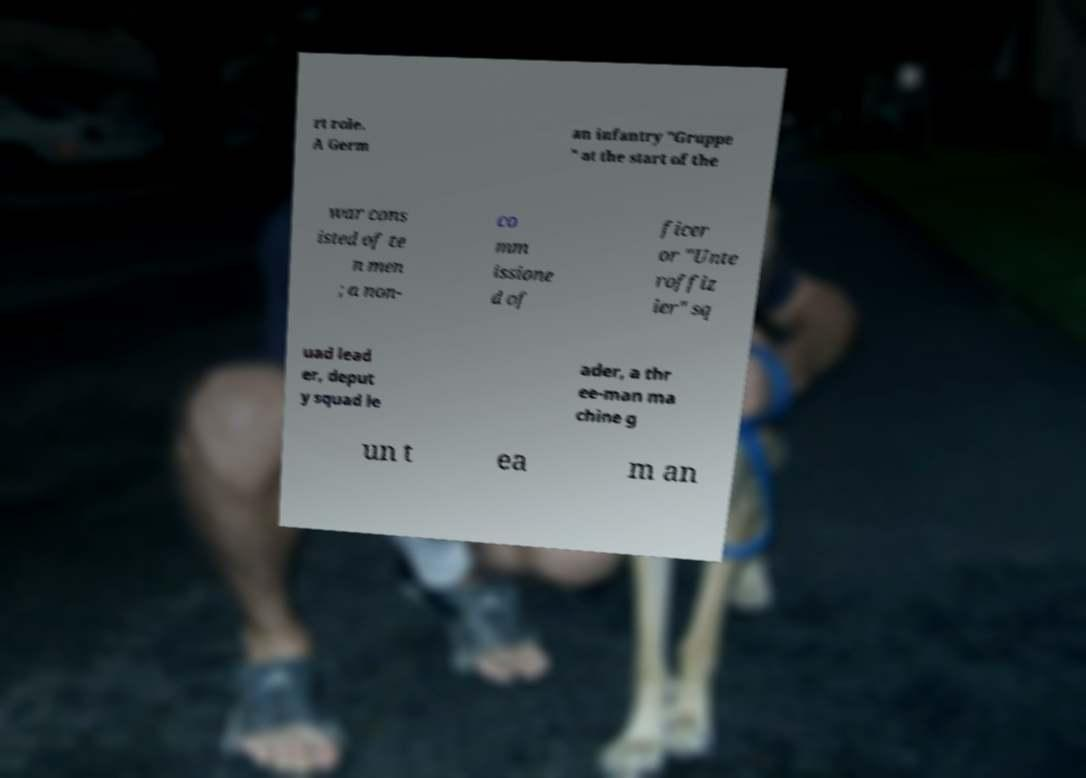I need the written content from this picture converted into text. Can you do that? rt role. A Germ an infantry "Gruppe " at the start of the war cons isted of te n men ; a non- co mm issione d of ficer or "Unte roffiz ier" sq uad lead er, deput y squad le ader, a thr ee-man ma chine g un t ea m an 